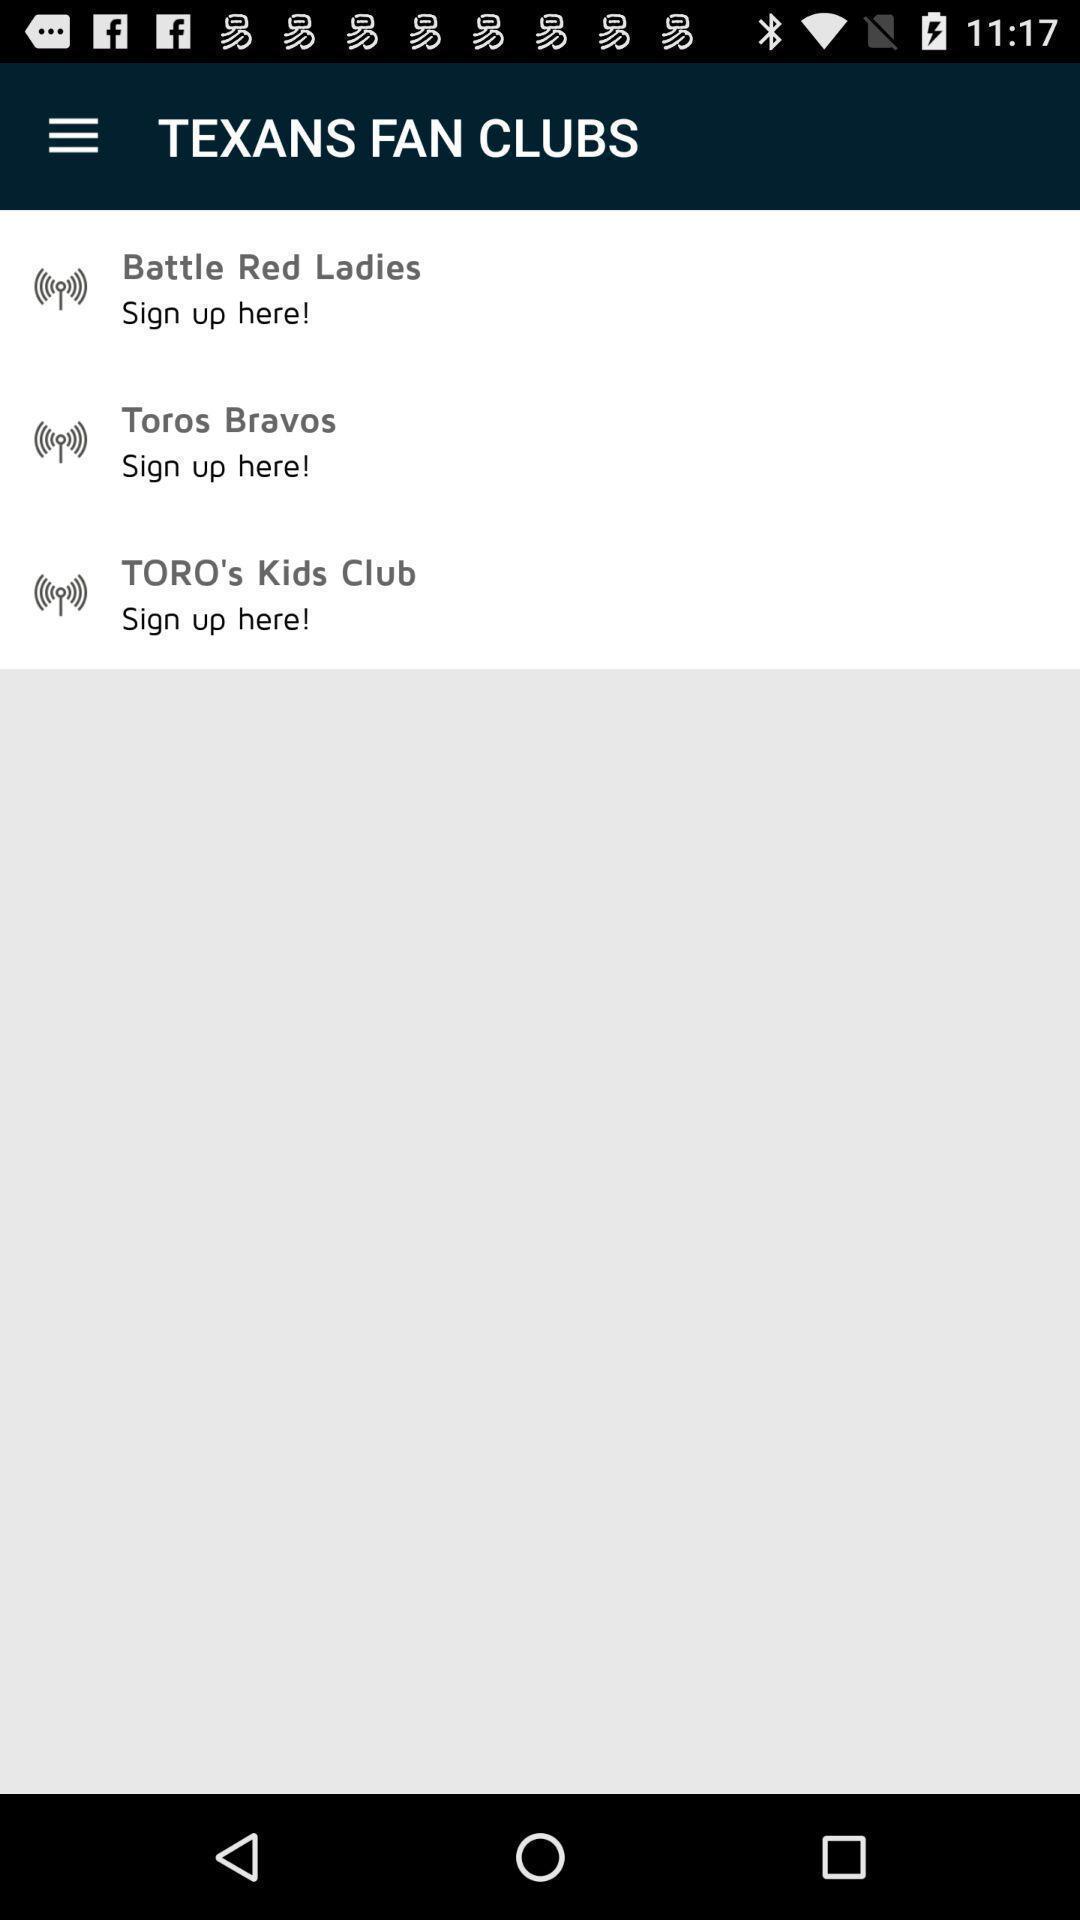Please provide a description for this image. Screen page displaying clubs page. 